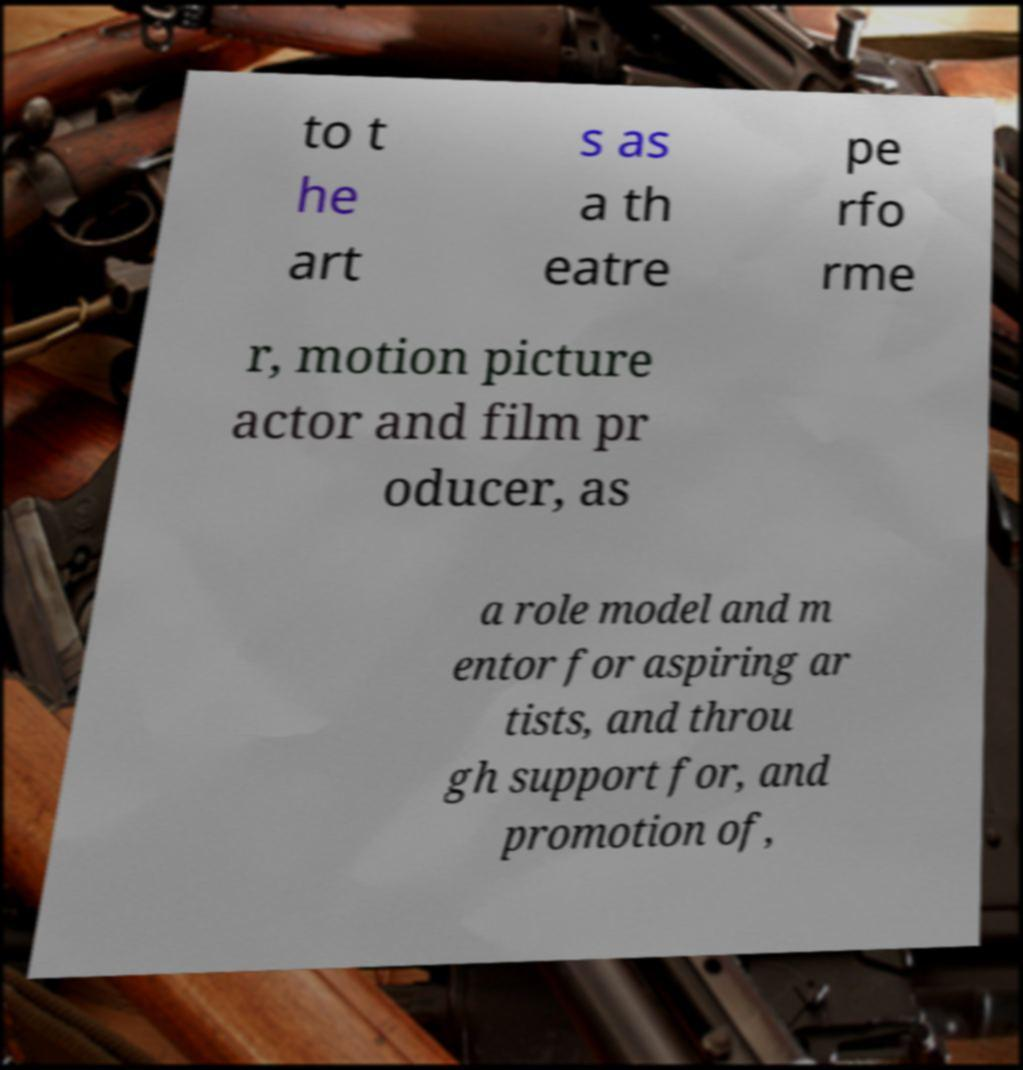Please identify and transcribe the text found in this image. to t he art s as a th eatre pe rfo rme r, motion picture actor and film pr oducer, as a role model and m entor for aspiring ar tists, and throu gh support for, and promotion of, 